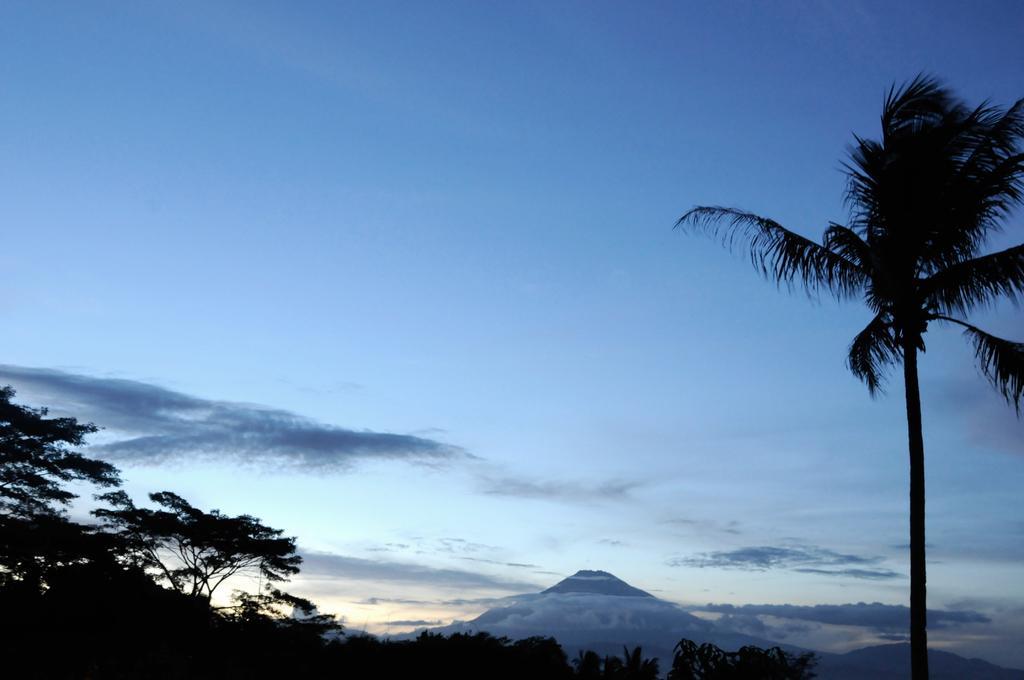How would you summarize this image in a sentence or two? In the center of the image we can see the sky, clouds, trees, hills etc. 